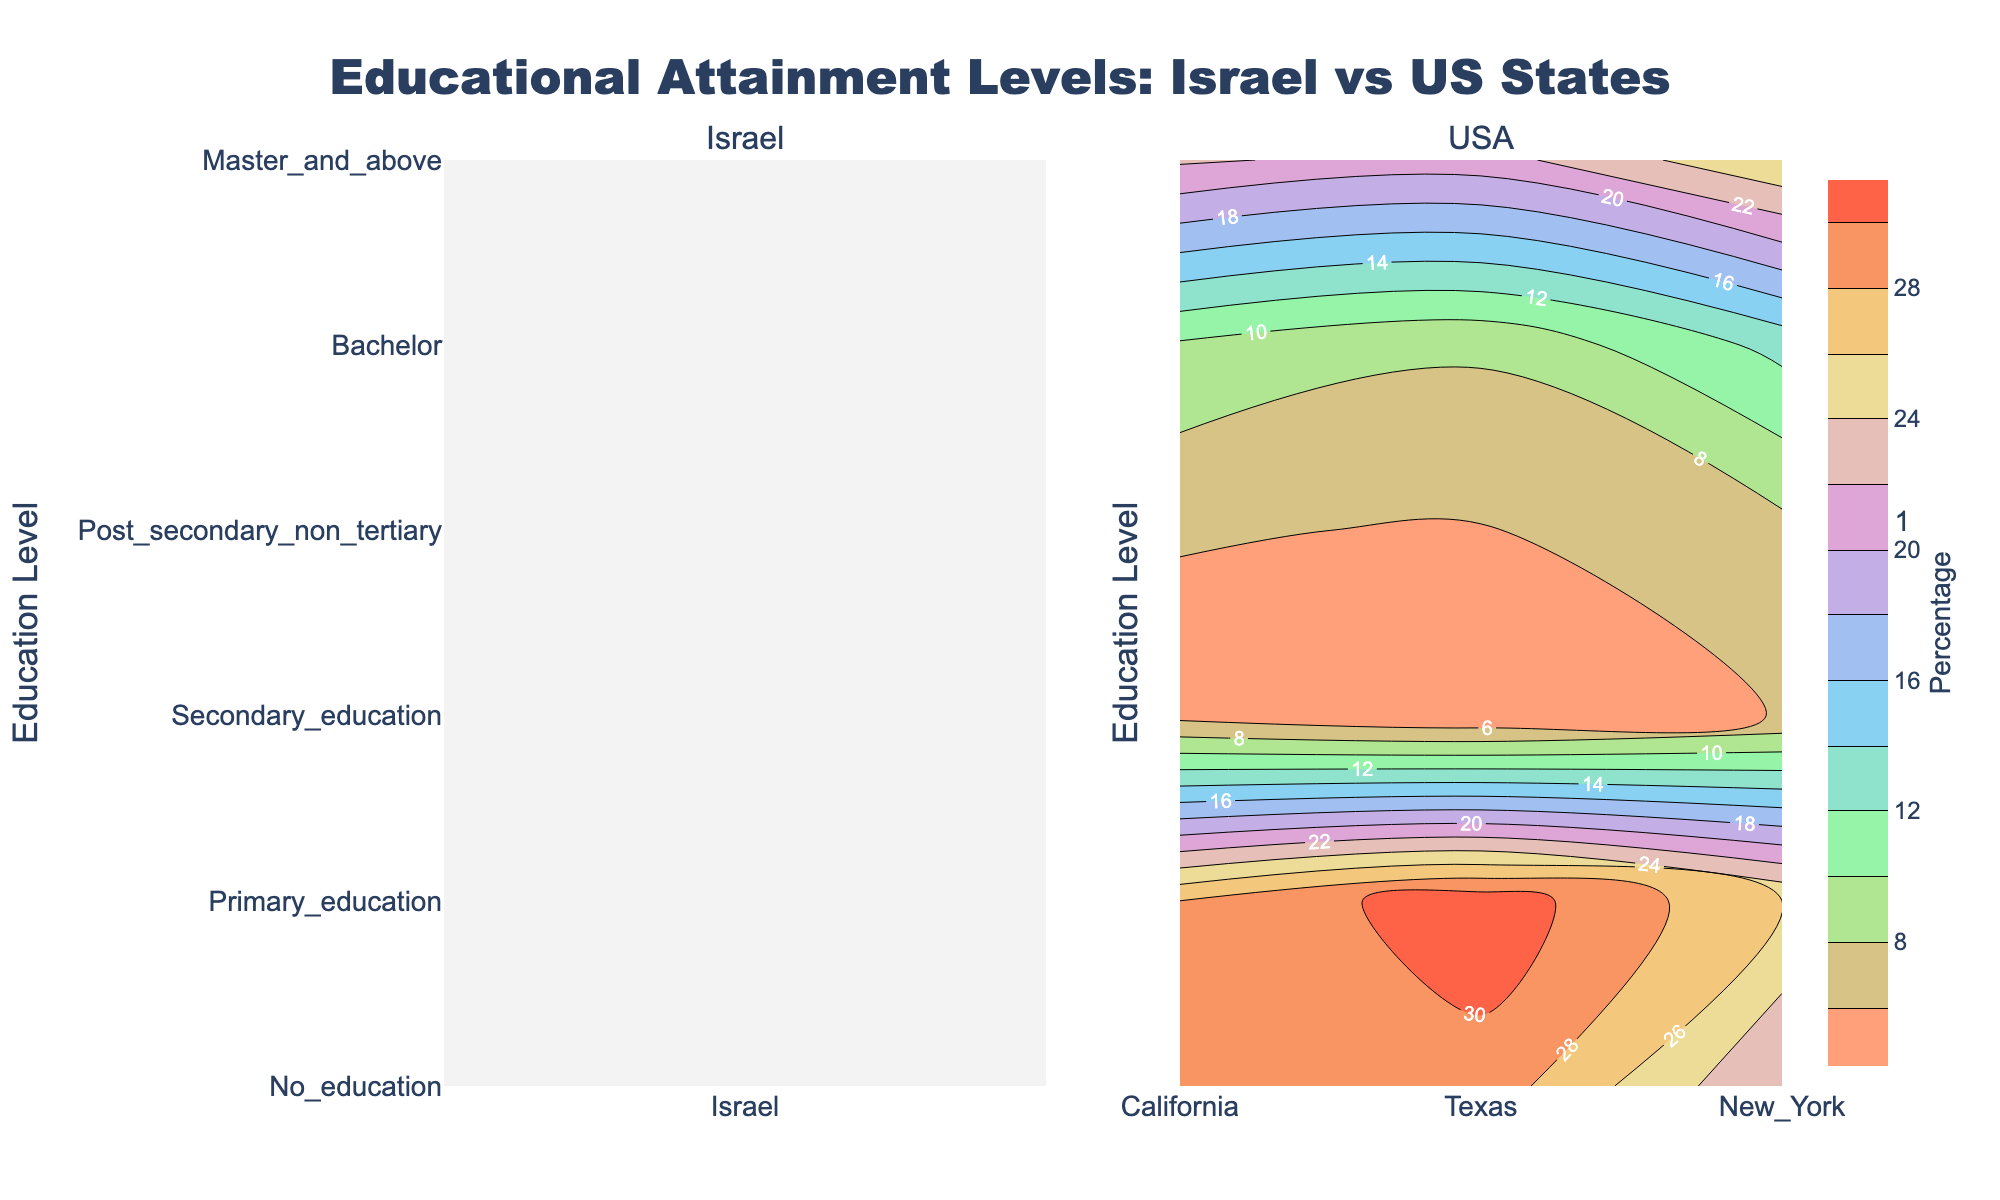what's the title of the figure? The title of the figure is located at the top and is prominently displayed in bold text. By observing the figure, the title reads "Educational Attainment Levels: Israel vs US States".
Answer: Educational Attainment Levels: Israel vs US States What is the highest educational attainment level represented in Israel? By examining the contour plot section for Israel, we can see the y-axis labeled with different educational attainment levels. The highest level is "Master and above" at 22.2%.
Answer: Master and above Which state in the USA has the lowest percentage of people without any education? Looking at the contour sections for each state, the lowest percentage of people with "No education" in the USA is found in New York at 4.2%
Answer: New York Compare the percentage of people with a Bachelor's degree between Israel and Texas. Which has a higher percentage? By examining the data in the contours for Israel and Texas, Israel has 34.1% in the Bachelor's category while Texas has 22%. Therefore, Israel has a higher percentage.
Answer: Israel How does the percentage of primary education in New York compare to that in California? Observe the contour sections for New York and California. New York displays 8.3% and California shows 9.7%. California has a higher primary education percentage compared to New York.
Answer: California What's the average percentage of Master's degree holders in the US states provided (California, Texas, New York)? To find the average percentage, we sum up the values for Master's and above in California (28.0%), Texas (26.0%), and New York (31.3%) and then divide by 3. (28.0 + 26.0 + 31.3) / 3 = 28.43%
Answer: 28.43% Which educational attainment level has the most similar percentage between California and New York? Compare the contours for California and New York across all educational levels. The "Bachelor" level is most similar, California = 28.6%, New York = 29.2%, a difference of only 0.6%.
Answer: Bachelor If we combine the percentages of secondary education and post-secondary non-tertiary education in Texas, what is the resulting sum? In the Texas contour, secondary education is 25.9% and post-secondary non-tertiary is 7.4%. Summing these gives 25.9 + 7.4 = 33.3%
Answer: 33.3% What is the combined percentage of people with higher education (Bachelor and above) in Israel? For Israel, the percentage for Bachelor's degree is 34.1% and Master's and above is 22.2%. The combined percentage is 34.1 + 22.2 = 56.3%
Answer: 56.3% 